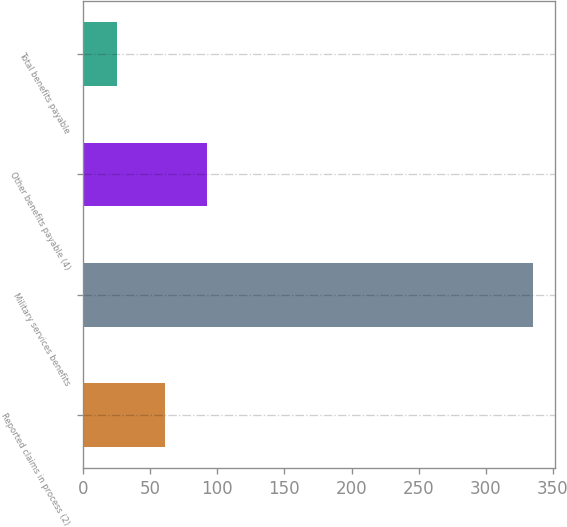Convert chart. <chart><loc_0><loc_0><loc_500><loc_500><bar_chart><fcel>Reported claims in process (2)<fcel>Military services benefits<fcel>Other benefits payable (4)<fcel>Total benefits payable<nl><fcel>61<fcel>335<fcel>92<fcel>25<nl></chart> 